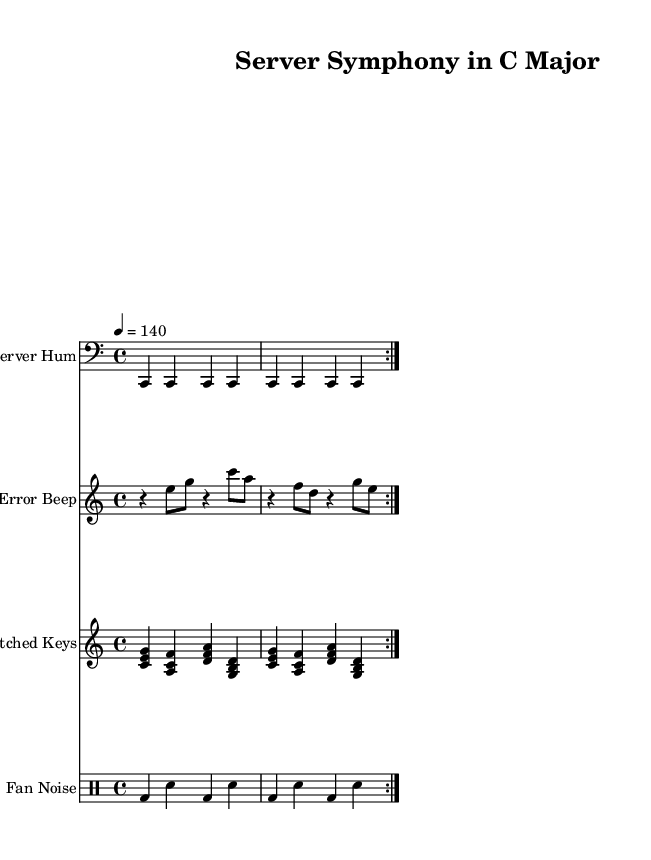What is the key signature of this music? The key signature indicated at the beginning of the sheet music is C major, which has no sharps or flats.
Answer: C major What is the time signature of this music? The time signature shown in the first measure is 4/4, indicating four beats per measure with a quarter note receiving one beat.
Answer: 4/4 What is the tempo marking for this piece? The tempo marking states "4 = 140", meaning that quarter notes are played at a speed of 140 beats per minute.
Answer: 140 How many times is the sampled server hum repeated? The notation for the sampled server hum shows a repetition indicated by "volta 2", which means it is repeated twice.
Answer: 2 What type of instrument is indicated for "Error Beep"? The "Error Beep" section specifies a staff for a melodic instrument, suggesting it is a keyboard or synthesizer.
Answer: Keyboard Why might "Glitched Keys" be considered experimental? The "Glitched Keys" section uses unconventional chords and patterns that evoke a sense of digital distortion, characteristic of experimental music.
Answer: Digital distortion How is the fan noise represented in the sheet music? The fan noise is represented using a drum staff, utilizing bass drums and snare drums in a repetitive pattern indicative of percussive elements.
Answer: Drum staff 